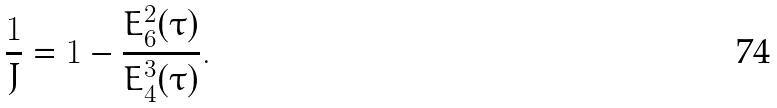Convert formula to latex. <formula><loc_0><loc_0><loc_500><loc_500>\frac { 1 } { J } = 1 - \frac { E _ { 6 } ^ { 2 } ( \tau ) } { E _ { 4 } ^ { 3 } ( \tau ) } .</formula> 